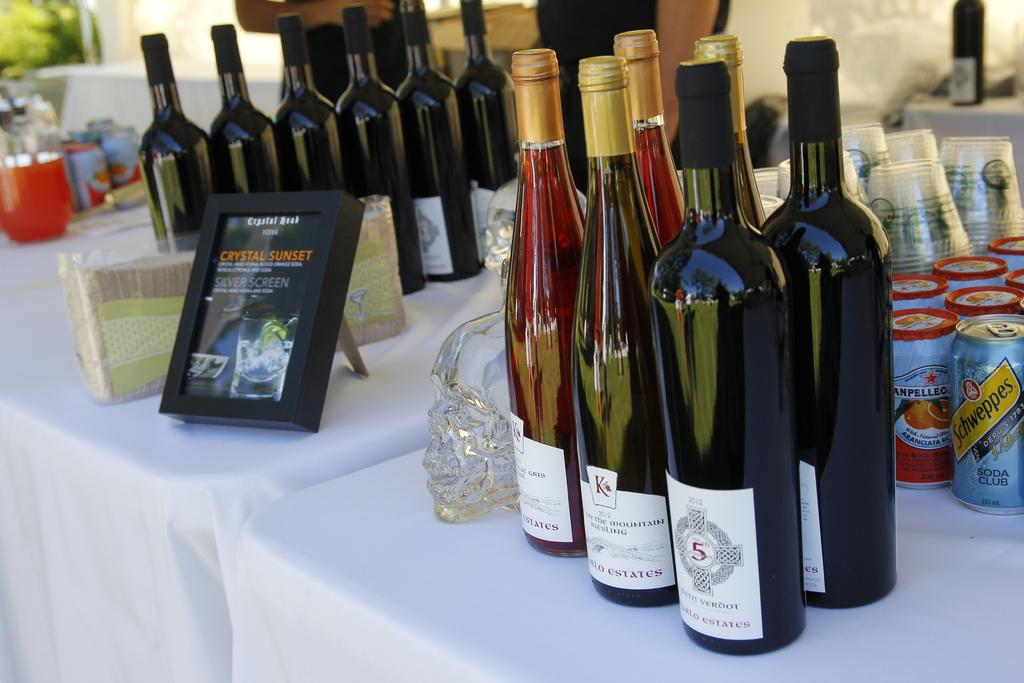<image>
Offer a succinct explanation of the picture presented. A framed flyer on a table of wine with the words Crystal Sunset on it. 